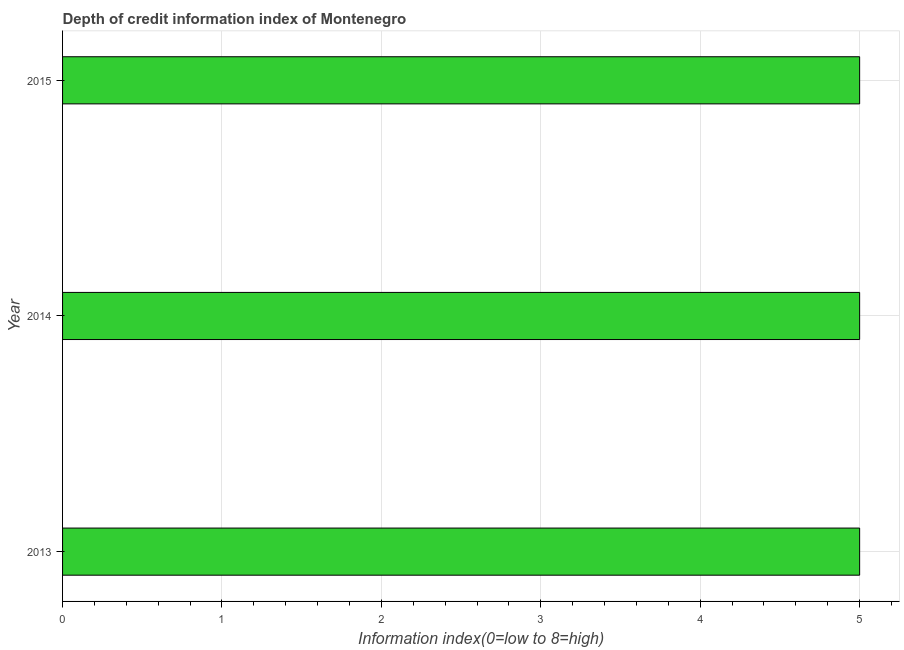Does the graph contain grids?
Offer a terse response. Yes. What is the title of the graph?
Provide a short and direct response. Depth of credit information index of Montenegro. What is the label or title of the X-axis?
Your response must be concise. Information index(0=low to 8=high). What is the label or title of the Y-axis?
Provide a succinct answer. Year. What is the depth of credit information index in 2013?
Keep it short and to the point. 5. In which year was the depth of credit information index minimum?
Give a very brief answer. 2013. In how many years, is the depth of credit information index greater than 2.4 ?
Make the answer very short. 3. Do a majority of the years between 2014 and 2013 (inclusive) have depth of credit information index greater than 2.6 ?
Your response must be concise. No. Is the difference between the depth of credit information index in 2013 and 2014 greater than the difference between any two years?
Keep it short and to the point. Yes. Is the sum of the depth of credit information index in 2013 and 2015 greater than the maximum depth of credit information index across all years?
Your response must be concise. Yes. What is the difference between the highest and the lowest depth of credit information index?
Keep it short and to the point. 0. In how many years, is the depth of credit information index greater than the average depth of credit information index taken over all years?
Offer a terse response. 0. How many bars are there?
Your answer should be very brief. 3. How many years are there in the graph?
Offer a terse response. 3. What is the Information index(0=low to 8=high) in 2013?
Ensure brevity in your answer.  5. What is the Information index(0=low to 8=high) of 2014?
Give a very brief answer. 5. What is the ratio of the Information index(0=low to 8=high) in 2013 to that in 2014?
Provide a succinct answer. 1. 